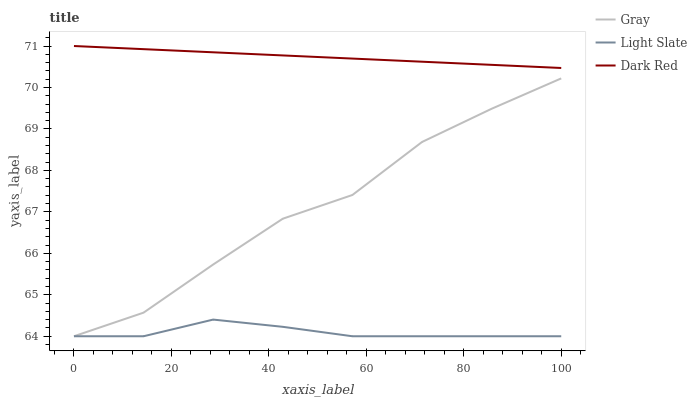Does Light Slate have the minimum area under the curve?
Answer yes or no. Yes. Does Dark Red have the maximum area under the curve?
Answer yes or no. Yes. Does Gray have the minimum area under the curve?
Answer yes or no. No. Does Gray have the maximum area under the curve?
Answer yes or no. No. Is Dark Red the smoothest?
Answer yes or no. Yes. Is Gray the roughest?
Answer yes or no. Yes. Is Gray the smoothest?
Answer yes or no. No. Is Dark Red the roughest?
Answer yes or no. No. Does Dark Red have the lowest value?
Answer yes or no. No. Does Dark Red have the highest value?
Answer yes or no. Yes. Does Gray have the highest value?
Answer yes or no. No. Is Light Slate less than Dark Red?
Answer yes or no. Yes. Is Dark Red greater than Light Slate?
Answer yes or no. Yes. Does Light Slate intersect Gray?
Answer yes or no. Yes. Is Light Slate less than Gray?
Answer yes or no. No. Is Light Slate greater than Gray?
Answer yes or no. No. Does Light Slate intersect Dark Red?
Answer yes or no. No. 